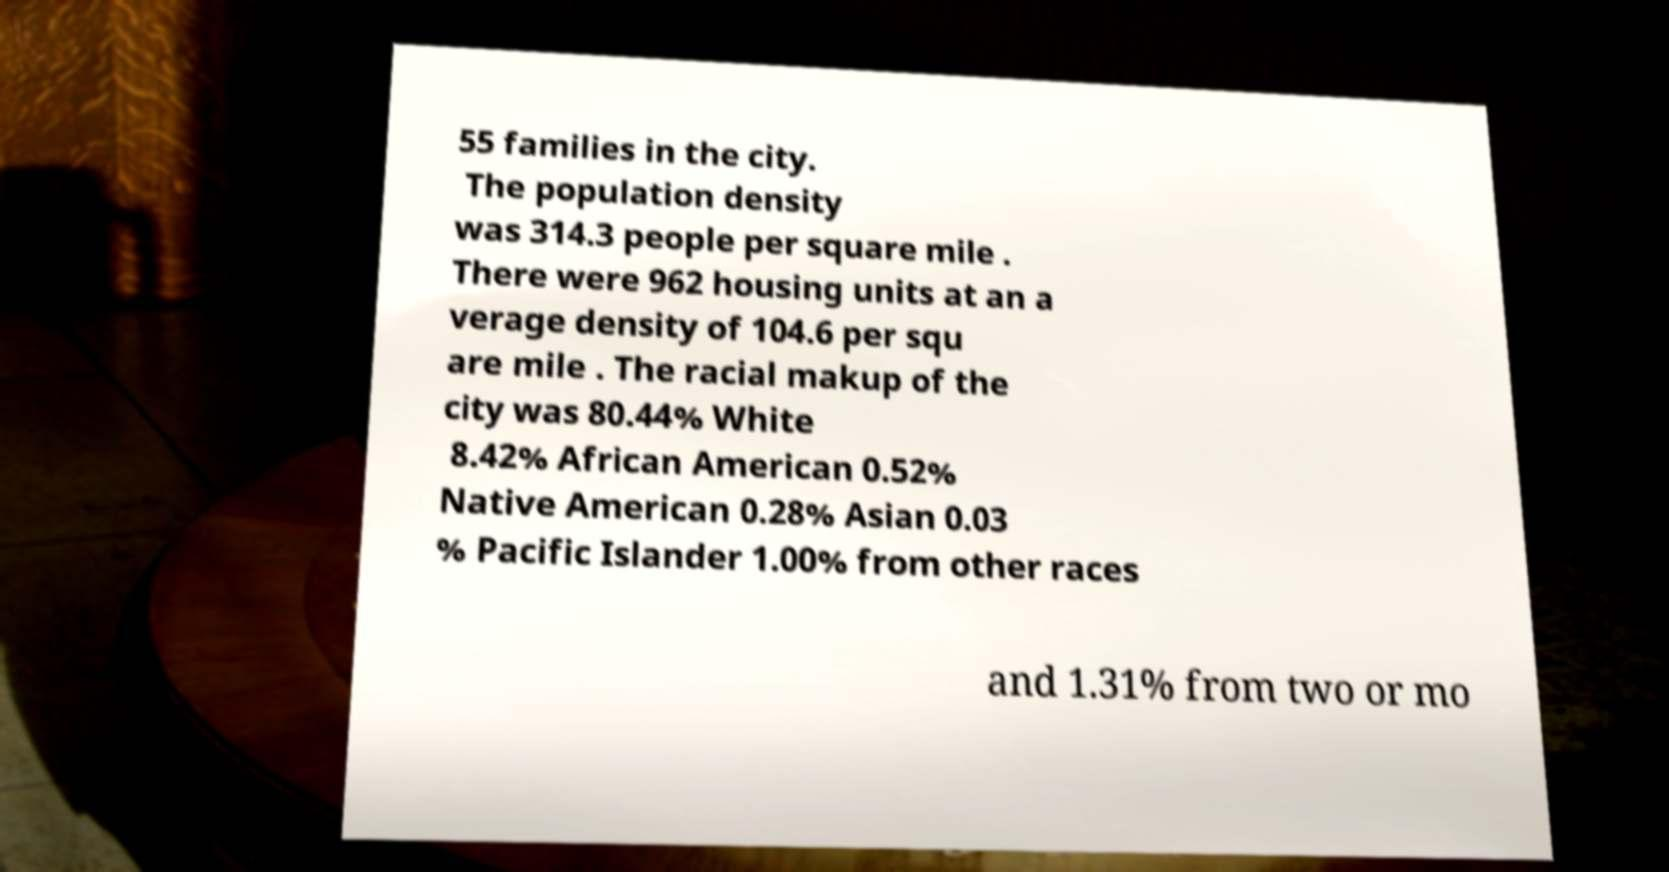Please identify and transcribe the text found in this image. 55 families in the city. The population density was 314.3 people per square mile . There were 962 housing units at an a verage density of 104.6 per squ are mile . The racial makup of the city was 80.44% White 8.42% African American 0.52% Native American 0.28% Asian 0.03 % Pacific Islander 1.00% from other races and 1.31% from two or mo 